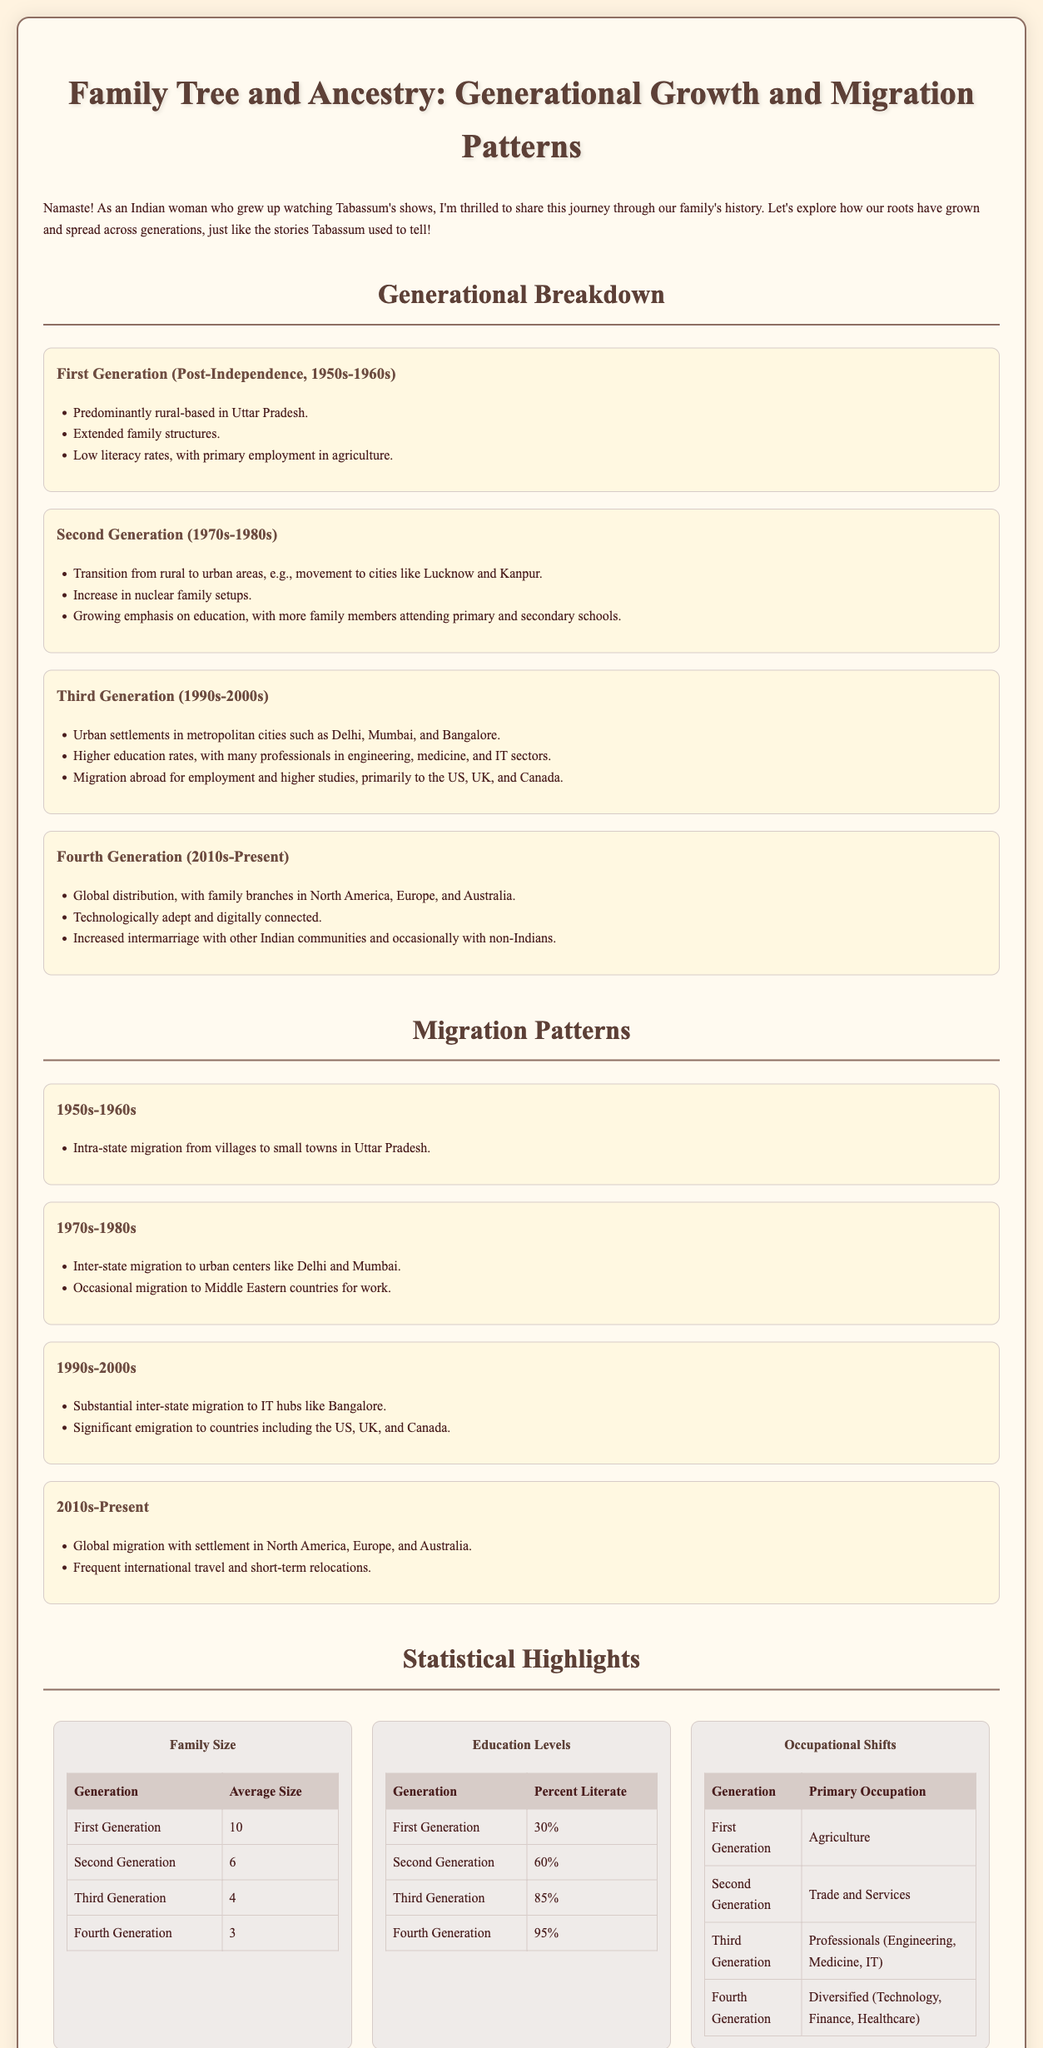What was the average family size in the first generation? The average family size in the first generation was stated in the document as 10.
Answer: 10 What percentage of the first generation was literate? The document provides that 30% of the first generation was literate.
Answer: 30% What was the primary occupation of the third generation? The document indicates that the primary occupation for the third generation was professionals in Engineering, Medicine, and IT.
Answer: Professionals (Engineering, Medicine, IT) Which generation saw a transition to nuclear family setups? The transition to nuclear family setups occurred in the second generation, as mentioned in the document.
Answer: Second Generation What is the average size of the fourth generation's family? The average size of the fourth generation's family is provided as 3 in the document.
Answer: 3 What key technological aspect distinguishes the fourth generation? The document mentions that the fourth generation is characterized as technologically adept and digitally connected.
Answer: Technologically adept and digitally connected How did migration patterns change from the 1970s to the 1980s? Migration patterns changed to include inter-state migration to urban centers like Delhi and Mumbai, as noted in the document.
Answer: Inter-state migration to urban centers What was the literate percentage of the second generation? The document states that 60% of the second generation was literate.
Answer: 60% What does the infographic primarily depict? The infographic primarily depicts generational growth and migration patterns in family trees and ancestry.
Answer: Generational growth and migration patterns 